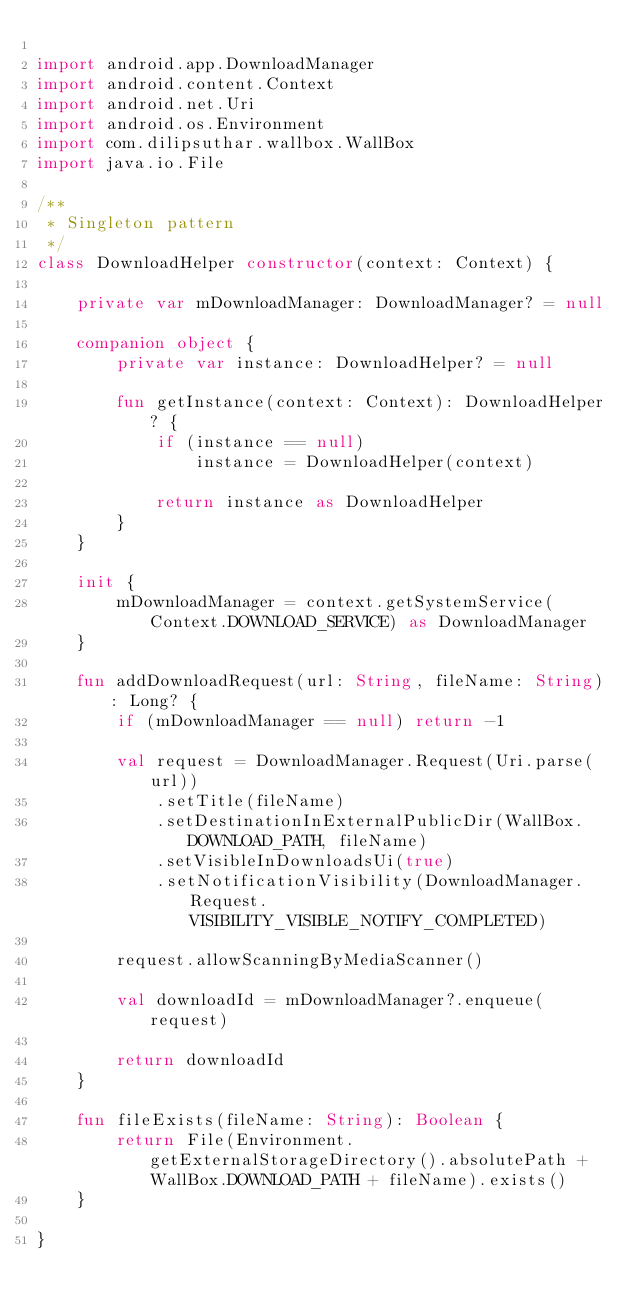<code> <loc_0><loc_0><loc_500><loc_500><_Kotlin_>
import android.app.DownloadManager
import android.content.Context
import android.net.Uri
import android.os.Environment
import com.dilipsuthar.wallbox.WallBox
import java.io.File

/**
 * Singleton pattern
 */
class DownloadHelper constructor(context: Context) {

    private var mDownloadManager: DownloadManager? = null

    companion object {
        private var instance: DownloadHelper? = null

        fun getInstance(context: Context): DownloadHelper? {
            if (instance == null)
                instance = DownloadHelper(context)

            return instance as DownloadHelper
        }
    }

    init {
        mDownloadManager = context.getSystemService(Context.DOWNLOAD_SERVICE) as DownloadManager
    }

    fun addDownloadRequest(url: String, fileName: String): Long? {
        if (mDownloadManager == null) return -1

        val request = DownloadManager.Request(Uri.parse(url))
            .setTitle(fileName)
            .setDestinationInExternalPublicDir(WallBox.DOWNLOAD_PATH, fileName)
            .setVisibleInDownloadsUi(true)
            .setNotificationVisibility(DownloadManager.Request.VISIBILITY_VISIBLE_NOTIFY_COMPLETED)

        request.allowScanningByMediaScanner()

        val downloadId = mDownloadManager?.enqueue(request)

        return downloadId
    }

    fun fileExists(fileName: String): Boolean {
        return File(Environment.getExternalStorageDirectory().absolutePath + WallBox.DOWNLOAD_PATH + fileName).exists()
    }

}</code> 